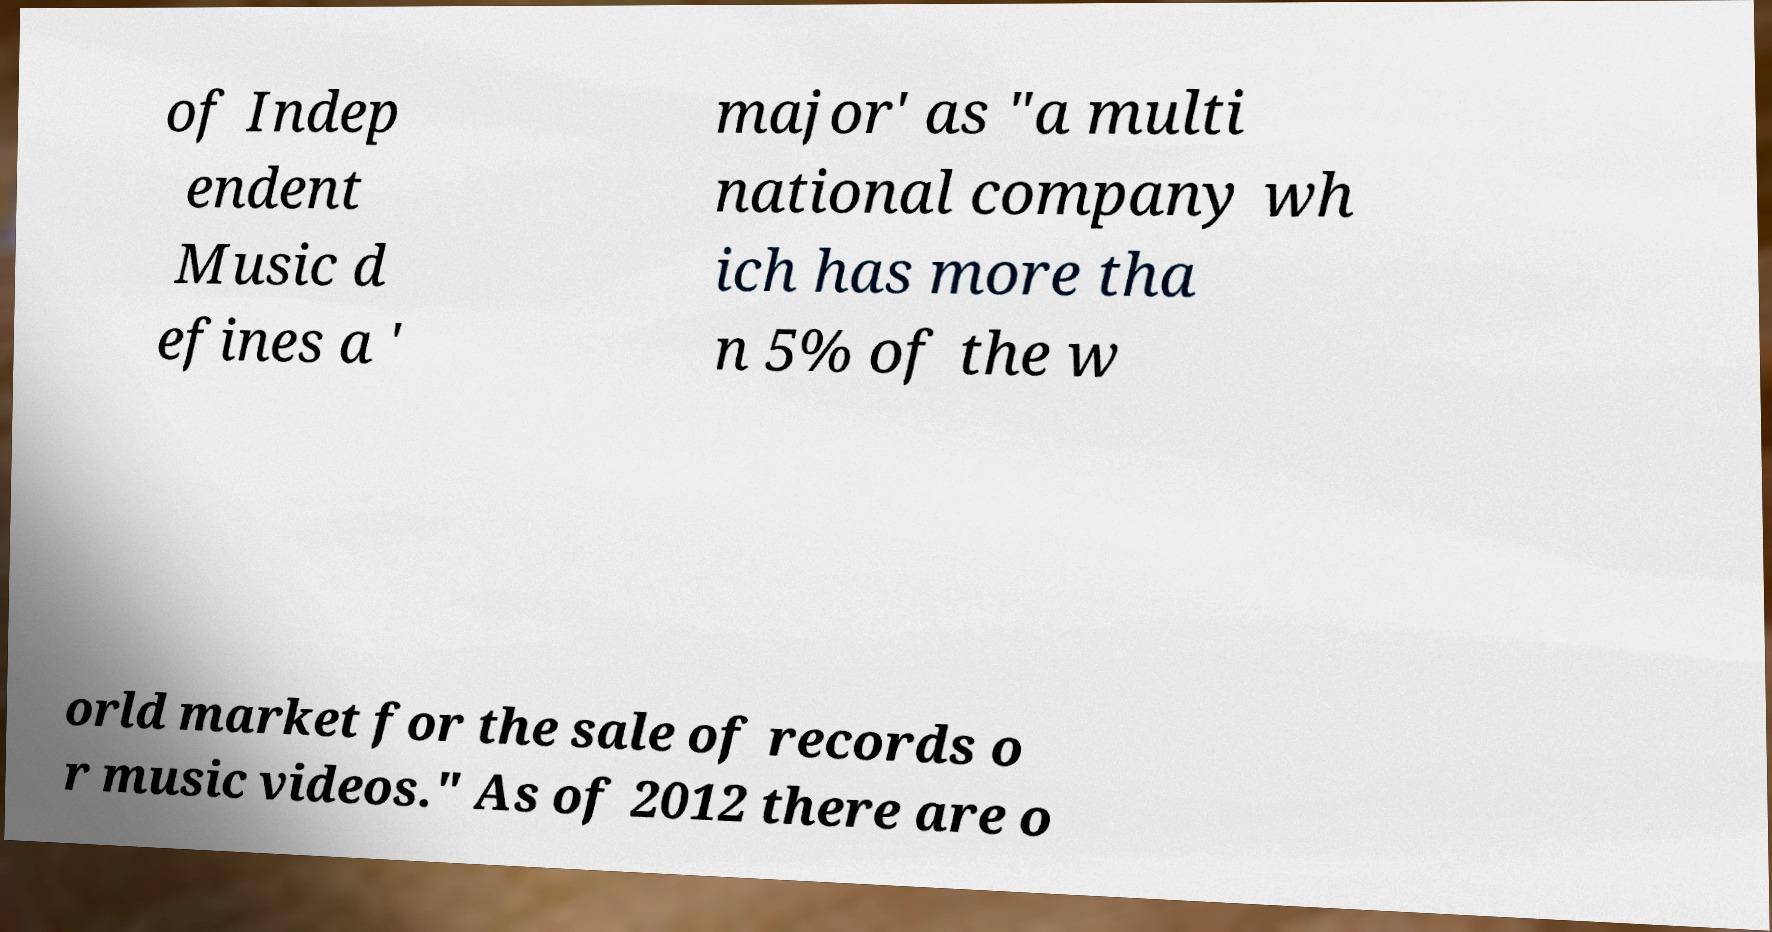Could you extract and type out the text from this image? of Indep endent Music d efines a ' major' as "a multi national company wh ich has more tha n 5% of the w orld market for the sale of records o r music videos." As of 2012 there are o 